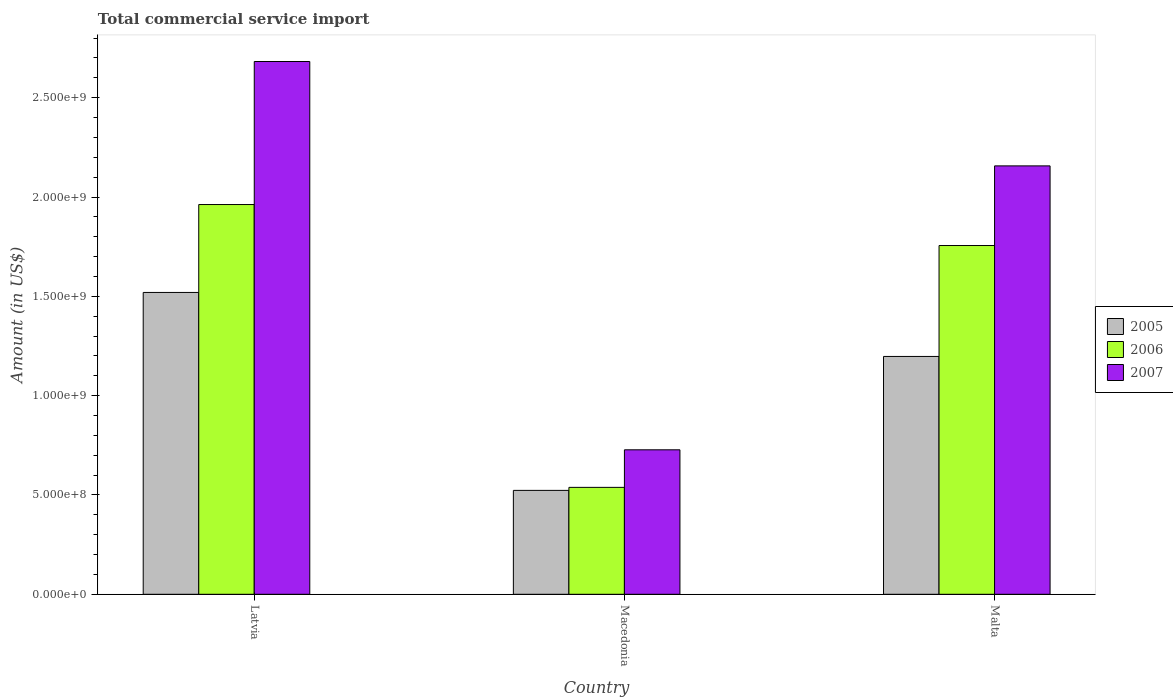How many different coloured bars are there?
Your response must be concise. 3. How many groups of bars are there?
Give a very brief answer. 3. Are the number of bars per tick equal to the number of legend labels?
Keep it short and to the point. Yes. How many bars are there on the 1st tick from the left?
Keep it short and to the point. 3. What is the label of the 2nd group of bars from the left?
Keep it short and to the point. Macedonia. What is the total commercial service import in 2005 in Malta?
Your answer should be compact. 1.20e+09. Across all countries, what is the maximum total commercial service import in 2007?
Ensure brevity in your answer.  2.68e+09. Across all countries, what is the minimum total commercial service import in 2005?
Provide a short and direct response. 5.23e+08. In which country was the total commercial service import in 2005 maximum?
Provide a succinct answer. Latvia. In which country was the total commercial service import in 2006 minimum?
Your answer should be very brief. Macedonia. What is the total total commercial service import in 2007 in the graph?
Ensure brevity in your answer.  5.57e+09. What is the difference between the total commercial service import in 2005 in Macedonia and that in Malta?
Ensure brevity in your answer.  -6.74e+08. What is the difference between the total commercial service import in 2005 in Malta and the total commercial service import in 2006 in Macedonia?
Keep it short and to the point. 6.59e+08. What is the average total commercial service import in 2005 per country?
Offer a very short reply. 1.08e+09. What is the difference between the total commercial service import of/in 2006 and total commercial service import of/in 2007 in Malta?
Give a very brief answer. -4.01e+08. In how many countries, is the total commercial service import in 2006 greater than 2600000000 US$?
Your answer should be compact. 0. What is the ratio of the total commercial service import in 2005 in Macedonia to that in Malta?
Provide a succinct answer. 0.44. Is the total commercial service import in 2005 in Latvia less than that in Malta?
Provide a short and direct response. No. Is the difference between the total commercial service import in 2006 in Macedonia and Malta greater than the difference between the total commercial service import in 2007 in Macedonia and Malta?
Offer a terse response. Yes. What is the difference between the highest and the second highest total commercial service import in 2006?
Keep it short and to the point. 1.42e+09. What is the difference between the highest and the lowest total commercial service import in 2006?
Make the answer very short. 1.42e+09. In how many countries, is the total commercial service import in 2007 greater than the average total commercial service import in 2007 taken over all countries?
Make the answer very short. 2. Is the sum of the total commercial service import in 2007 in Latvia and Macedonia greater than the maximum total commercial service import in 2005 across all countries?
Provide a short and direct response. Yes. What does the 1st bar from the left in Malta represents?
Your response must be concise. 2005. How many bars are there?
Give a very brief answer. 9. Are all the bars in the graph horizontal?
Provide a short and direct response. No. How many countries are there in the graph?
Make the answer very short. 3. Are the values on the major ticks of Y-axis written in scientific E-notation?
Offer a terse response. Yes. Does the graph contain any zero values?
Offer a very short reply. No. How many legend labels are there?
Offer a terse response. 3. What is the title of the graph?
Your answer should be compact. Total commercial service import. Does "1974" appear as one of the legend labels in the graph?
Ensure brevity in your answer.  No. What is the label or title of the Y-axis?
Provide a succinct answer. Amount (in US$). What is the Amount (in US$) in 2005 in Latvia?
Keep it short and to the point. 1.52e+09. What is the Amount (in US$) in 2006 in Latvia?
Keep it short and to the point. 1.96e+09. What is the Amount (in US$) of 2007 in Latvia?
Offer a terse response. 2.68e+09. What is the Amount (in US$) in 2005 in Macedonia?
Make the answer very short. 5.23e+08. What is the Amount (in US$) of 2006 in Macedonia?
Make the answer very short. 5.38e+08. What is the Amount (in US$) of 2007 in Macedonia?
Offer a very short reply. 7.27e+08. What is the Amount (in US$) in 2005 in Malta?
Your answer should be very brief. 1.20e+09. What is the Amount (in US$) of 2006 in Malta?
Your answer should be very brief. 1.76e+09. What is the Amount (in US$) of 2007 in Malta?
Offer a very short reply. 2.16e+09. Across all countries, what is the maximum Amount (in US$) in 2005?
Ensure brevity in your answer.  1.52e+09. Across all countries, what is the maximum Amount (in US$) in 2006?
Ensure brevity in your answer.  1.96e+09. Across all countries, what is the maximum Amount (in US$) in 2007?
Give a very brief answer. 2.68e+09. Across all countries, what is the minimum Amount (in US$) in 2005?
Your response must be concise. 5.23e+08. Across all countries, what is the minimum Amount (in US$) of 2006?
Keep it short and to the point. 5.38e+08. Across all countries, what is the minimum Amount (in US$) in 2007?
Offer a terse response. 7.27e+08. What is the total Amount (in US$) of 2005 in the graph?
Offer a terse response. 3.24e+09. What is the total Amount (in US$) of 2006 in the graph?
Provide a short and direct response. 4.26e+09. What is the total Amount (in US$) of 2007 in the graph?
Keep it short and to the point. 5.57e+09. What is the difference between the Amount (in US$) of 2005 in Latvia and that in Macedonia?
Your answer should be very brief. 9.97e+08. What is the difference between the Amount (in US$) in 2006 in Latvia and that in Macedonia?
Your answer should be compact. 1.42e+09. What is the difference between the Amount (in US$) in 2007 in Latvia and that in Macedonia?
Offer a very short reply. 1.95e+09. What is the difference between the Amount (in US$) in 2005 in Latvia and that in Malta?
Offer a very short reply. 3.22e+08. What is the difference between the Amount (in US$) of 2006 in Latvia and that in Malta?
Offer a very short reply. 2.06e+08. What is the difference between the Amount (in US$) of 2007 in Latvia and that in Malta?
Offer a very short reply. 5.25e+08. What is the difference between the Amount (in US$) of 2005 in Macedonia and that in Malta?
Offer a terse response. -6.74e+08. What is the difference between the Amount (in US$) of 2006 in Macedonia and that in Malta?
Provide a succinct answer. -1.22e+09. What is the difference between the Amount (in US$) of 2007 in Macedonia and that in Malta?
Your answer should be very brief. -1.43e+09. What is the difference between the Amount (in US$) in 2005 in Latvia and the Amount (in US$) in 2006 in Macedonia?
Offer a very short reply. 9.81e+08. What is the difference between the Amount (in US$) of 2005 in Latvia and the Amount (in US$) of 2007 in Macedonia?
Provide a short and direct response. 7.92e+08. What is the difference between the Amount (in US$) in 2006 in Latvia and the Amount (in US$) in 2007 in Macedonia?
Provide a short and direct response. 1.23e+09. What is the difference between the Amount (in US$) of 2005 in Latvia and the Amount (in US$) of 2006 in Malta?
Your answer should be very brief. -2.36e+08. What is the difference between the Amount (in US$) of 2005 in Latvia and the Amount (in US$) of 2007 in Malta?
Your answer should be very brief. -6.37e+08. What is the difference between the Amount (in US$) of 2006 in Latvia and the Amount (in US$) of 2007 in Malta?
Provide a short and direct response. -1.95e+08. What is the difference between the Amount (in US$) of 2005 in Macedonia and the Amount (in US$) of 2006 in Malta?
Ensure brevity in your answer.  -1.23e+09. What is the difference between the Amount (in US$) of 2005 in Macedonia and the Amount (in US$) of 2007 in Malta?
Make the answer very short. -1.63e+09. What is the difference between the Amount (in US$) of 2006 in Macedonia and the Amount (in US$) of 2007 in Malta?
Give a very brief answer. -1.62e+09. What is the average Amount (in US$) in 2005 per country?
Ensure brevity in your answer.  1.08e+09. What is the average Amount (in US$) in 2006 per country?
Ensure brevity in your answer.  1.42e+09. What is the average Amount (in US$) in 2007 per country?
Your response must be concise. 1.86e+09. What is the difference between the Amount (in US$) in 2005 and Amount (in US$) in 2006 in Latvia?
Offer a very short reply. -4.42e+08. What is the difference between the Amount (in US$) of 2005 and Amount (in US$) of 2007 in Latvia?
Provide a short and direct response. -1.16e+09. What is the difference between the Amount (in US$) in 2006 and Amount (in US$) in 2007 in Latvia?
Offer a terse response. -7.20e+08. What is the difference between the Amount (in US$) in 2005 and Amount (in US$) in 2006 in Macedonia?
Your answer should be compact. -1.52e+07. What is the difference between the Amount (in US$) in 2005 and Amount (in US$) in 2007 in Macedonia?
Make the answer very short. -2.04e+08. What is the difference between the Amount (in US$) of 2006 and Amount (in US$) of 2007 in Macedonia?
Provide a succinct answer. -1.89e+08. What is the difference between the Amount (in US$) in 2005 and Amount (in US$) in 2006 in Malta?
Provide a short and direct response. -5.58e+08. What is the difference between the Amount (in US$) of 2005 and Amount (in US$) of 2007 in Malta?
Ensure brevity in your answer.  -9.59e+08. What is the difference between the Amount (in US$) in 2006 and Amount (in US$) in 2007 in Malta?
Ensure brevity in your answer.  -4.01e+08. What is the ratio of the Amount (in US$) in 2005 in Latvia to that in Macedonia?
Your response must be concise. 2.91. What is the ratio of the Amount (in US$) in 2006 in Latvia to that in Macedonia?
Your response must be concise. 3.65. What is the ratio of the Amount (in US$) of 2007 in Latvia to that in Macedonia?
Provide a succinct answer. 3.69. What is the ratio of the Amount (in US$) in 2005 in Latvia to that in Malta?
Make the answer very short. 1.27. What is the ratio of the Amount (in US$) of 2006 in Latvia to that in Malta?
Give a very brief answer. 1.12. What is the ratio of the Amount (in US$) of 2007 in Latvia to that in Malta?
Your response must be concise. 1.24. What is the ratio of the Amount (in US$) in 2005 in Macedonia to that in Malta?
Give a very brief answer. 0.44. What is the ratio of the Amount (in US$) of 2006 in Macedonia to that in Malta?
Make the answer very short. 0.31. What is the ratio of the Amount (in US$) of 2007 in Macedonia to that in Malta?
Offer a very short reply. 0.34. What is the difference between the highest and the second highest Amount (in US$) in 2005?
Make the answer very short. 3.22e+08. What is the difference between the highest and the second highest Amount (in US$) in 2006?
Your answer should be compact. 2.06e+08. What is the difference between the highest and the second highest Amount (in US$) in 2007?
Your answer should be compact. 5.25e+08. What is the difference between the highest and the lowest Amount (in US$) of 2005?
Keep it short and to the point. 9.97e+08. What is the difference between the highest and the lowest Amount (in US$) in 2006?
Offer a very short reply. 1.42e+09. What is the difference between the highest and the lowest Amount (in US$) in 2007?
Your answer should be very brief. 1.95e+09. 